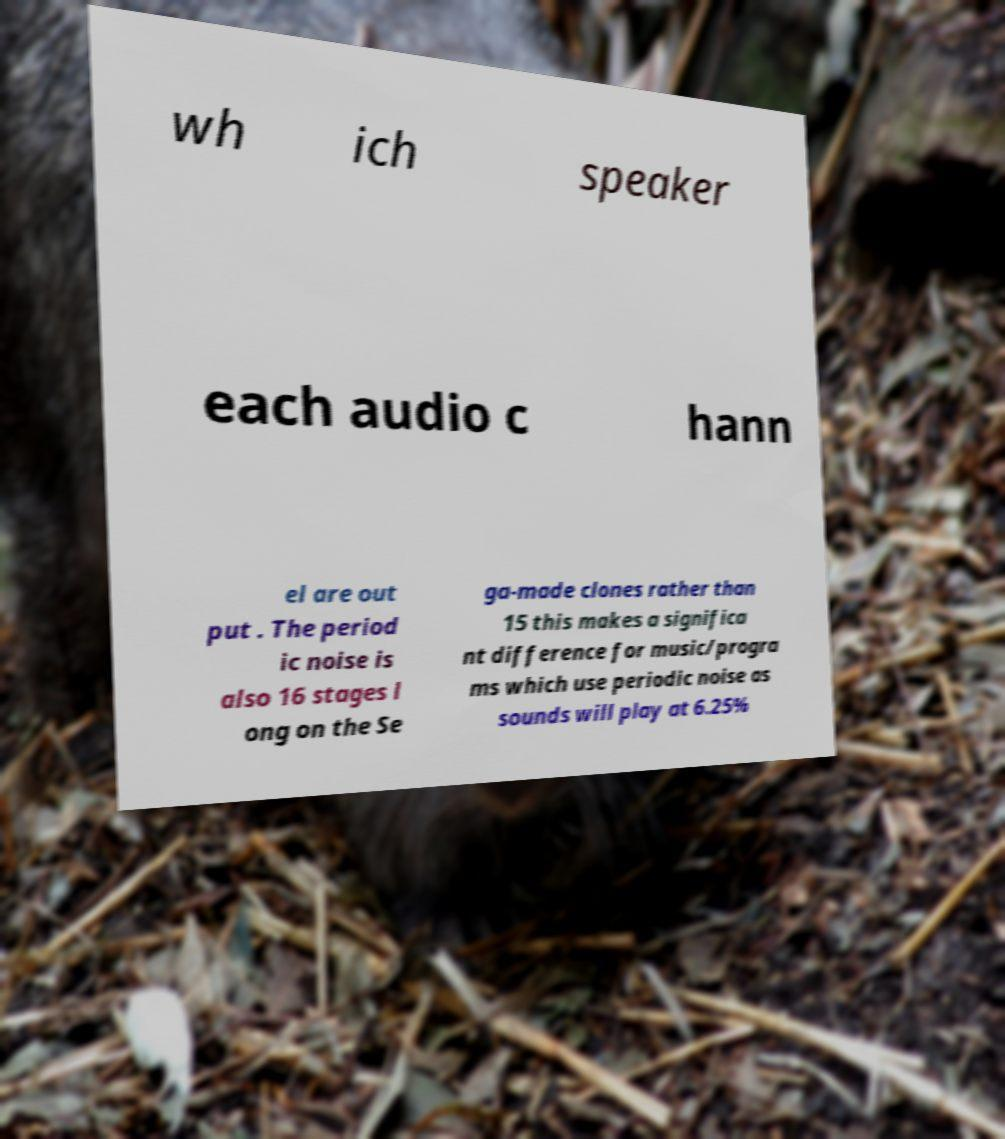There's text embedded in this image that I need extracted. Can you transcribe it verbatim? wh ich speaker each audio c hann el are out put . The period ic noise is also 16 stages l ong on the Se ga-made clones rather than 15 this makes a significa nt difference for music/progra ms which use periodic noise as sounds will play at 6.25% 